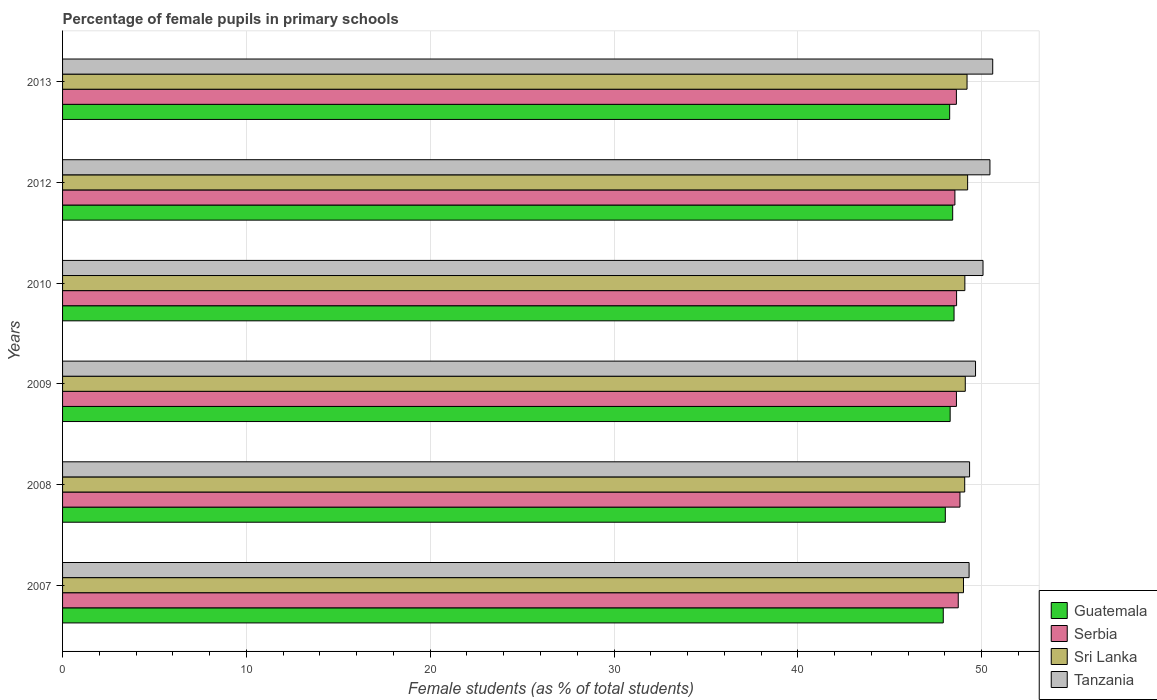How many different coloured bars are there?
Make the answer very short. 4. Are the number of bars per tick equal to the number of legend labels?
Provide a short and direct response. Yes. Are the number of bars on each tick of the Y-axis equal?
Offer a terse response. Yes. How many bars are there on the 5th tick from the bottom?
Make the answer very short. 4. What is the percentage of female pupils in primary schools in Serbia in 2009?
Make the answer very short. 48.63. Across all years, what is the maximum percentage of female pupils in primary schools in Serbia?
Offer a terse response. 48.82. Across all years, what is the minimum percentage of female pupils in primary schools in Sri Lanka?
Offer a very short reply. 49.01. What is the total percentage of female pupils in primary schools in Serbia in the graph?
Make the answer very short. 291.99. What is the difference between the percentage of female pupils in primary schools in Guatemala in 2012 and that in 2013?
Ensure brevity in your answer.  0.16. What is the difference between the percentage of female pupils in primary schools in Sri Lanka in 2008 and the percentage of female pupils in primary schools in Guatemala in 2007?
Your answer should be compact. 1.17. What is the average percentage of female pupils in primary schools in Sri Lanka per year?
Give a very brief answer. 49.12. In the year 2009, what is the difference between the percentage of female pupils in primary schools in Sri Lanka and percentage of female pupils in primary schools in Tanzania?
Provide a short and direct response. -0.56. What is the ratio of the percentage of female pupils in primary schools in Tanzania in 2012 to that in 2013?
Ensure brevity in your answer.  1. What is the difference between the highest and the second highest percentage of female pupils in primary schools in Sri Lanka?
Your answer should be very brief. 0.03. What is the difference between the highest and the lowest percentage of female pupils in primary schools in Tanzania?
Give a very brief answer. 1.29. Is the sum of the percentage of female pupils in primary schools in Tanzania in 2007 and 2010 greater than the maximum percentage of female pupils in primary schools in Guatemala across all years?
Keep it short and to the point. Yes. Is it the case that in every year, the sum of the percentage of female pupils in primary schools in Tanzania and percentage of female pupils in primary schools in Serbia is greater than the sum of percentage of female pupils in primary schools in Guatemala and percentage of female pupils in primary schools in Sri Lanka?
Make the answer very short. No. What does the 3rd bar from the top in 2012 represents?
Your response must be concise. Serbia. What does the 2nd bar from the bottom in 2012 represents?
Keep it short and to the point. Serbia. How many bars are there?
Provide a succinct answer. 24. What is the difference between two consecutive major ticks on the X-axis?
Give a very brief answer. 10. Where does the legend appear in the graph?
Ensure brevity in your answer.  Bottom right. How many legend labels are there?
Provide a succinct answer. 4. What is the title of the graph?
Provide a succinct answer. Percentage of female pupils in primary schools. Does "Slovak Republic" appear as one of the legend labels in the graph?
Offer a terse response. No. What is the label or title of the X-axis?
Give a very brief answer. Female students (as % of total students). What is the label or title of the Y-axis?
Your answer should be very brief. Years. What is the Female students (as % of total students) in Guatemala in 2007?
Your answer should be very brief. 47.91. What is the Female students (as % of total students) in Serbia in 2007?
Offer a terse response. 48.73. What is the Female students (as % of total students) of Sri Lanka in 2007?
Your answer should be very brief. 49.01. What is the Female students (as % of total students) in Tanzania in 2007?
Offer a terse response. 49.32. What is the Female students (as % of total students) in Guatemala in 2008?
Keep it short and to the point. 48.02. What is the Female students (as % of total students) of Serbia in 2008?
Provide a succinct answer. 48.82. What is the Female students (as % of total students) of Sri Lanka in 2008?
Make the answer very short. 49.08. What is the Female students (as % of total students) in Tanzania in 2008?
Make the answer very short. 49.34. What is the Female students (as % of total students) in Guatemala in 2009?
Offer a terse response. 48.29. What is the Female students (as % of total students) in Serbia in 2009?
Your answer should be compact. 48.63. What is the Female students (as % of total students) of Sri Lanka in 2009?
Your answer should be very brief. 49.11. What is the Female students (as % of total students) of Tanzania in 2009?
Give a very brief answer. 49.67. What is the Female students (as % of total students) in Guatemala in 2010?
Your answer should be compact. 48.5. What is the Female students (as % of total students) of Serbia in 2010?
Offer a very short reply. 48.64. What is the Female students (as % of total students) in Sri Lanka in 2010?
Give a very brief answer. 49.09. What is the Female students (as % of total students) of Tanzania in 2010?
Make the answer very short. 50.08. What is the Female students (as % of total students) in Guatemala in 2012?
Your answer should be very brief. 48.43. What is the Female students (as % of total students) of Serbia in 2012?
Your answer should be compact. 48.55. What is the Female students (as % of total students) of Sri Lanka in 2012?
Give a very brief answer. 49.24. What is the Female students (as % of total students) of Tanzania in 2012?
Your answer should be very brief. 50.45. What is the Female students (as % of total students) in Guatemala in 2013?
Give a very brief answer. 48.26. What is the Female students (as % of total students) of Serbia in 2013?
Offer a terse response. 48.63. What is the Female students (as % of total students) of Sri Lanka in 2013?
Provide a succinct answer. 49.21. What is the Female students (as % of total students) in Tanzania in 2013?
Give a very brief answer. 50.6. Across all years, what is the maximum Female students (as % of total students) in Guatemala?
Offer a very short reply. 48.5. Across all years, what is the maximum Female students (as % of total students) of Serbia?
Give a very brief answer. 48.82. Across all years, what is the maximum Female students (as % of total students) in Sri Lanka?
Give a very brief answer. 49.24. Across all years, what is the maximum Female students (as % of total students) in Tanzania?
Your response must be concise. 50.6. Across all years, what is the minimum Female students (as % of total students) in Guatemala?
Give a very brief answer. 47.91. Across all years, what is the minimum Female students (as % of total students) in Serbia?
Provide a short and direct response. 48.55. Across all years, what is the minimum Female students (as % of total students) of Sri Lanka?
Provide a short and direct response. 49.01. Across all years, what is the minimum Female students (as % of total students) in Tanzania?
Offer a very short reply. 49.32. What is the total Female students (as % of total students) of Guatemala in the graph?
Ensure brevity in your answer.  289.41. What is the total Female students (as % of total students) of Serbia in the graph?
Ensure brevity in your answer.  291.99. What is the total Female students (as % of total students) of Sri Lanka in the graph?
Keep it short and to the point. 294.74. What is the total Female students (as % of total students) in Tanzania in the graph?
Make the answer very short. 299.46. What is the difference between the Female students (as % of total students) in Guatemala in 2007 and that in 2008?
Your answer should be compact. -0.11. What is the difference between the Female students (as % of total students) of Serbia in 2007 and that in 2008?
Your response must be concise. -0.09. What is the difference between the Female students (as % of total students) of Sri Lanka in 2007 and that in 2008?
Keep it short and to the point. -0.07. What is the difference between the Female students (as % of total students) of Tanzania in 2007 and that in 2008?
Provide a succinct answer. -0.03. What is the difference between the Female students (as % of total students) in Guatemala in 2007 and that in 2009?
Make the answer very short. -0.37. What is the difference between the Female students (as % of total students) of Serbia in 2007 and that in 2009?
Offer a terse response. 0.1. What is the difference between the Female students (as % of total students) in Sri Lanka in 2007 and that in 2009?
Offer a terse response. -0.1. What is the difference between the Female students (as % of total students) of Tanzania in 2007 and that in 2009?
Ensure brevity in your answer.  -0.35. What is the difference between the Female students (as % of total students) in Guatemala in 2007 and that in 2010?
Offer a terse response. -0.59. What is the difference between the Female students (as % of total students) of Serbia in 2007 and that in 2010?
Keep it short and to the point. 0.09. What is the difference between the Female students (as % of total students) of Sri Lanka in 2007 and that in 2010?
Offer a terse response. -0.07. What is the difference between the Female students (as % of total students) of Tanzania in 2007 and that in 2010?
Ensure brevity in your answer.  -0.76. What is the difference between the Female students (as % of total students) of Guatemala in 2007 and that in 2012?
Your answer should be compact. -0.51. What is the difference between the Female students (as % of total students) in Serbia in 2007 and that in 2012?
Provide a succinct answer. 0.18. What is the difference between the Female students (as % of total students) in Sri Lanka in 2007 and that in 2012?
Ensure brevity in your answer.  -0.23. What is the difference between the Female students (as % of total students) of Tanzania in 2007 and that in 2012?
Ensure brevity in your answer.  -1.13. What is the difference between the Female students (as % of total students) of Guatemala in 2007 and that in 2013?
Provide a short and direct response. -0.35. What is the difference between the Female students (as % of total students) in Serbia in 2007 and that in 2013?
Provide a succinct answer. 0.1. What is the difference between the Female students (as % of total students) in Sri Lanka in 2007 and that in 2013?
Your response must be concise. -0.19. What is the difference between the Female students (as % of total students) in Tanzania in 2007 and that in 2013?
Your answer should be compact. -1.29. What is the difference between the Female students (as % of total students) in Guatemala in 2008 and that in 2009?
Make the answer very short. -0.26. What is the difference between the Female students (as % of total students) of Serbia in 2008 and that in 2009?
Make the answer very short. 0.19. What is the difference between the Female students (as % of total students) in Sri Lanka in 2008 and that in 2009?
Offer a terse response. -0.03. What is the difference between the Female students (as % of total students) in Tanzania in 2008 and that in 2009?
Provide a short and direct response. -0.32. What is the difference between the Female students (as % of total students) of Guatemala in 2008 and that in 2010?
Ensure brevity in your answer.  -0.47. What is the difference between the Female students (as % of total students) of Serbia in 2008 and that in 2010?
Keep it short and to the point. 0.18. What is the difference between the Female students (as % of total students) of Sri Lanka in 2008 and that in 2010?
Keep it short and to the point. -0.01. What is the difference between the Female students (as % of total students) of Tanzania in 2008 and that in 2010?
Make the answer very short. -0.73. What is the difference between the Female students (as % of total students) of Guatemala in 2008 and that in 2012?
Provide a succinct answer. -0.4. What is the difference between the Female students (as % of total students) in Serbia in 2008 and that in 2012?
Provide a succinct answer. 0.28. What is the difference between the Female students (as % of total students) of Sri Lanka in 2008 and that in 2012?
Your answer should be compact. -0.16. What is the difference between the Female students (as % of total students) of Tanzania in 2008 and that in 2012?
Offer a terse response. -1.11. What is the difference between the Female students (as % of total students) in Guatemala in 2008 and that in 2013?
Give a very brief answer. -0.24. What is the difference between the Female students (as % of total students) in Serbia in 2008 and that in 2013?
Provide a short and direct response. 0.19. What is the difference between the Female students (as % of total students) in Sri Lanka in 2008 and that in 2013?
Make the answer very short. -0.13. What is the difference between the Female students (as % of total students) of Tanzania in 2008 and that in 2013?
Give a very brief answer. -1.26. What is the difference between the Female students (as % of total students) in Guatemala in 2009 and that in 2010?
Offer a very short reply. -0.21. What is the difference between the Female students (as % of total students) in Serbia in 2009 and that in 2010?
Offer a terse response. -0.01. What is the difference between the Female students (as % of total students) of Sri Lanka in 2009 and that in 2010?
Provide a short and direct response. 0.02. What is the difference between the Female students (as % of total students) of Tanzania in 2009 and that in 2010?
Offer a terse response. -0.41. What is the difference between the Female students (as % of total students) in Guatemala in 2009 and that in 2012?
Provide a short and direct response. -0.14. What is the difference between the Female students (as % of total students) in Serbia in 2009 and that in 2012?
Your answer should be compact. 0.08. What is the difference between the Female students (as % of total students) in Sri Lanka in 2009 and that in 2012?
Your response must be concise. -0.13. What is the difference between the Female students (as % of total students) in Tanzania in 2009 and that in 2012?
Give a very brief answer. -0.78. What is the difference between the Female students (as % of total students) of Guatemala in 2009 and that in 2013?
Keep it short and to the point. 0.03. What is the difference between the Female students (as % of total students) of Serbia in 2009 and that in 2013?
Your answer should be compact. 0. What is the difference between the Female students (as % of total students) of Sri Lanka in 2009 and that in 2013?
Provide a short and direct response. -0.1. What is the difference between the Female students (as % of total students) in Tanzania in 2009 and that in 2013?
Keep it short and to the point. -0.93. What is the difference between the Female students (as % of total students) of Guatemala in 2010 and that in 2012?
Keep it short and to the point. 0.07. What is the difference between the Female students (as % of total students) in Serbia in 2010 and that in 2012?
Your response must be concise. 0.09. What is the difference between the Female students (as % of total students) in Sri Lanka in 2010 and that in 2012?
Keep it short and to the point. -0.15. What is the difference between the Female students (as % of total students) of Tanzania in 2010 and that in 2012?
Offer a very short reply. -0.38. What is the difference between the Female students (as % of total students) of Guatemala in 2010 and that in 2013?
Your answer should be very brief. 0.24. What is the difference between the Female students (as % of total students) of Serbia in 2010 and that in 2013?
Your answer should be very brief. 0.01. What is the difference between the Female students (as % of total students) in Sri Lanka in 2010 and that in 2013?
Offer a very short reply. -0.12. What is the difference between the Female students (as % of total students) in Tanzania in 2010 and that in 2013?
Make the answer very short. -0.53. What is the difference between the Female students (as % of total students) in Guatemala in 2012 and that in 2013?
Your answer should be compact. 0.16. What is the difference between the Female students (as % of total students) of Serbia in 2012 and that in 2013?
Give a very brief answer. -0.08. What is the difference between the Female students (as % of total students) of Sri Lanka in 2012 and that in 2013?
Offer a very short reply. 0.03. What is the difference between the Female students (as % of total students) in Tanzania in 2012 and that in 2013?
Your response must be concise. -0.15. What is the difference between the Female students (as % of total students) in Guatemala in 2007 and the Female students (as % of total students) in Serbia in 2008?
Make the answer very short. -0.91. What is the difference between the Female students (as % of total students) in Guatemala in 2007 and the Female students (as % of total students) in Sri Lanka in 2008?
Make the answer very short. -1.17. What is the difference between the Female students (as % of total students) of Guatemala in 2007 and the Female students (as % of total students) of Tanzania in 2008?
Your answer should be compact. -1.43. What is the difference between the Female students (as % of total students) in Serbia in 2007 and the Female students (as % of total students) in Sri Lanka in 2008?
Keep it short and to the point. -0.35. What is the difference between the Female students (as % of total students) in Serbia in 2007 and the Female students (as % of total students) in Tanzania in 2008?
Keep it short and to the point. -0.62. What is the difference between the Female students (as % of total students) in Sri Lanka in 2007 and the Female students (as % of total students) in Tanzania in 2008?
Keep it short and to the point. -0.33. What is the difference between the Female students (as % of total students) in Guatemala in 2007 and the Female students (as % of total students) in Serbia in 2009?
Your response must be concise. -0.72. What is the difference between the Female students (as % of total students) of Guatemala in 2007 and the Female students (as % of total students) of Sri Lanka in 2009?
Keep it short and to the point. -1.2. What is the difference between the Female students (as % of total students) of Guatemala in 2007 and the Female students (as % of total students) of Tanzania in 2009?
Make the answer very short. -1.76. What is the difference between the Female students (as % of total students) of Serbia in 2007 and the Female students (as % of total students) of Sri Lanka in 2009?
Your answer should be compact. -0.38. What is the difference between the Female students (as % of total students) in Serbia in 2007 and the Female students (as % of total students) in Tanzania in 2009?
Provide a succinct answer. -0.94. What is the difference between the Female students (as % of total students) in Sri Lanka in 2007 and the Female students (as % of total students) in Tanzania in 2009?
Make the answer very short. -0.66. What is the difference between the Female students (as % of total students) of Guatemala in 2007 and the Female students (as % of total students) of Serbia in 2010?
Your response must be concise. -0.72. What is the difference between the Female students (as % of total students) in Guatemala in 2007 and the Female students (as % of total students) in Sri Lanka in 2010?
Make the answer very short. -1.17. What is the difference between the Female students (as % of total students) of Guatemala in 2007 and the Female students (as % of total students) of Tanzania in 2010?
Provide a succinct answer. -2.16. What is the difference between the Female students (as % of total students) in Serbia in 2007 and the Female students (as % of total students) in Sri Lanka in 2010?
Keep it short and to the point. -0.36. What is the difference between the Female students (as % of total students) in Serbia in 2007 and the Female students (as % of total students) in Tanzania in 2010?
Provide a short and direct response. -1.35. What is the difference between the Female students (as % of total students) of Sri Lanka in 2007 and the Female students (as % of total students) of Tanzania in 2010?
Your answer should be very brief. -1.06. What is the difference between the Female students (as % of total students) in Guatemala in 2007 and the Female students (as % of total students) in Serbia in 2012?
Offer a terse response. -0.63. What is the difference between the Female students (as % of total students) in Guatemala in 2007 and the Female students (as % of total students) in Sri Lanka in 2012?
Offer a terse response. -1.33. What is the difference between the Female students (as % of total students) of Guatemala in 2007 and the Female students (as % of total students) of Tanzania in 2012?
Provide a short and direct response. -2.54. What is the difference between the Female students (as % of total students) in Serbia in 2007 and the Female students (as % of total students) in Sri Lanka in 2012?
Give a very brief answer. -0.51. What is the difference between the Female students (as % of total students) of Serbia in 2007 and the Female students (as % of total students) of Tanzania in 2012?
Give a very brief answer. -1.72. What is the difference between the Female students (as % of total students) in Sri Lanka in 2007 and the Female students (as % of total students) in Tanzania in 2012?
Make the answer very short. -1.44. What is the difference between the Female students (as % of total students) in Guatemala in 2007 and the Female students (as % of total students) in Serbia in 2013?
Offer a terse response. -0.71. What is the difference between the Female students (as % of total students) in Guatemala in 2007 and the Female students (as % of total students) in Sri Lanka in 2013?
Keep it short and to the point. -1.29. What is the difference between the Female students (as % of total students) of Guatemala in 2007 and the Female students (as % of total students) of Tanzania in 2013?
Provide a short and direct response. -2.69. What is the difference between the Female students (as % of total students) of Serbia in 2007 and the Female students (as % of total students) of Sri Lanka in 2013?
Your answer should be very brief. -0.48. What is the difference between the Female students (as % of total students) in Serbia in 2007 and the Female students (as % of total students) in Tanzania in 2013?
Your answer should be very brief. -1.88. What is the difference between the Female students (as % of total students) of Sri Lanka in 2007 and the Female students (as % of total students) of Tanzania in 2013?
Provide a short and direct response. -1.59. What is the difference between the Female students (as % of total students) in Guatemala in 2008 and the Female students (as % of total students) in Serbia in 2009?
Ensure brevity in your answer.  -0.6. What is the difference between the Female students (as % of total students) of Guatemala in 2008 and the Female students (as % of total students) of Sri Lanka in 2009?
Your response must be concise. -1.09. What is the difference between the Female students (as % of total students) of Guatemala in 2008 and the Female students (as % of total students) of Tanzania in 2009?
Provide a short and direct response. -1.64. What is the difference between the Female students (as % of total students) in Serbia in 2008 and the Female students (as % of total students) in Sri Lanka in 2009?
Offer a terse response. -0.29. What is the difference between the Female students (as % of total students) of Serbia in 2008 and the Female students (as % of total students) of Tanzania in 2009?
Offer a terse response. -0.85. What is the difference between the Female students (as % of total students) in Sri Lanka in 2008 and the Female students (as % of total students) in Tanzania in 2009?
Offer a very short reply. -0.59. What is the difference between the Female students (as % of total students) in Guatemala in 2008 and the Female students (as % of total students) in Serbia in 2010?
Provide a short and direct response. -0.61. What is the difference between the Female students (as % of total students) in Guatemala in 2008 and the Female students (as % of total students) in Sri Lanka in 2010?
Keep it short and to the point. -1.06. What is the difference between the Female students (as % of total students) of Guatemala in 2008 and the Female students (as % of total students) of Tanzania in 2010?
Your response must be concise. -2.05. What is the difference between the Female students (as % of total students) of Serbia in 2008 and the Female students (as % of total students) of Sri Lanka in 2010?
Make the answer very short. -0.27. What is the difference between the Female students (as % of total students) of Serbia in 2008 and the Female students (as % of total students) of Tanzania in 2010?
Give a very brief answer. -1.25. What is the difference between the Female students (as % of total students) of Sri Lanka in 2008 and the Female students (as % of total students) of Tanzania in 2010?
Provide a succinct answer. -1. What is the difference between the Female students (as % of total students) of Guatemala in 2008 and the Female students (as % of total students) of Serbia in 2012?
Keep it short and to the point. -0.52. What is the difference between the Female students (as % of total students) of Guatemala in 2008 and the Female students (as % of total students) of Sri Lanka in 2012?
Offer a terse response. -1.21. What is the difference between the Female students (as % of total students) in Guatemala in 2008 and the Female students (as % of total students) in Tanzania in 2012?
Make the answer very short. -2.43. What is the difference between the Female students (as % of total students) in Serbia in 2008 and the Female students (as % of total students) in Sri Lanka in 2012?
Your answer should be compact. -0.42. What is the difference between the Female students (as % of total students) of Serbia in 2008 and the Female students (as % of total students) of Tanzania in 2012?
Provide a short and direct response. -1.63. What is the difference between the Female students (as % of total students) in Sri Lanka in 2008 and the Female students (as % of total students) in Tanzania in 2012?
Keep it short and to the point. -1.37. What is the difference between the Female students (as % of total students) in Guatemala in 2008 and the Female students (as % of total students) in Serbia in 2013?
Offer a very short reply. -0.6. What is the difference between the Female students (as % of total students) of Guatemala in 2008 and the Female students (as % of total students) of Sri Lanka in 2013?
Offer a terse response. -1.18. What is the difference between the Female students (as % of total students) of Guatemala in 2008 and the Female students (as % of total students) of Tanzania in 2013?
Ensure brevity in your answer.  -2.58. What is the difference between the Female students (as % of total students) in Serbia in 2008 and the Female students (as % of total students) in Sri Lanka in 2013?
Make the answer very short. -0.38. What is the difference between the Female students (as % of total students) in Serbia in 2008 and the Female students (as % of total students) in Tanzania in 2013?
Keep it short and to the point. -1.78. What is the difference between the Female students (as % of total students) in Sri Lanka in 2008 and the Female students (as % of total students) in Tanzania in 2013?
Provide a short and direct response. -1.52. What is the difference between the Female students (as % of total students) in Guatemala in 2009 and the Female students (as % of total students) in Serbia in 2010?
Make the answer very short. -0.35. What is the difference between the Female students (as % of total students) of Guatemala in 2009 and the Female students (as % of total students) of Sri Lanka in 2010?
Give a very brief answer. -0.8. What is the difference between the Female students (as % of total students) of Guatemala in 2009 and the Female students (as % of total students) of Tanzania in 2010?
Your response must be concise. -1.79. What is the difference between the Female students (as % of total students) of Serbia in 2009 and the Female students (as % of total students) of Sri Lanka in 2010?
Your response must be concise. -0.46. What is the difference between the Female students (as % of total students) in Serbia in 2009 and the Female students (as % of total students) in Tanzania in 2010?
Make the answer very short. -1.45. What is the difference between the Female students (as % of total students) of Sri Lanka in 2009 and the Female students (as % of total students) of Tanzania in 2010?
Make the answer very short. -0.97. What is the difference between the Female students (as % of total students) of Guatemala in 2009 and the Female students (as % of total students) of Serbia in 2012?
Your answer should be compact. -0.26. What is the difference between the Female students (as % of total students) of Guatemala in 2009 and the Female students (as % of total students) of Sri Lanka in 2012?
Your answer should be very brief. -0.95. What is the difference between the Female students (as % of total students) in Guatemala in 2009 and the Female students (as % of total students) in Tanzania in 2012?
Provide a succinct answer. -2.16. What is the difference between the Female students (as % of total students) in Serbia in 2009 and the Female students (as % of total students) in Sri Lanka in 2012?
Your response must be concise. -0.61. What is the difference between the Female students (as % of total students) of Serbia in 2009 and the Female students (as % of total students) of Tanzania in 2012?
Offer a terse response. -1.82. What is the difference between the Female students (as % of total students) of Sri Lanka in 2009 and the Female students (as % of total students) of Tanzania in 2012?
Your answer should be compact. -1.34. What is the difference between the Female students (as % of total students) in Guatemala in 2009 and the Female students (as % of total students) in Serbia in 2013?
Offer a terse response. -0.34. What is the difference between the Female students (as % of total students) of Guatemala in 2009 and the Female students (as % of total students) of Sri Lanka in 2013?
Keep it short and to the point. -0.92. What is the difference between the Female students (as % of total students) of Guatemala in 2009 and the Female students (as % of total students) of Tanzania in 2013?
Keep it short and to the point. -2.32. What is the difference between the Female students (as % of total students) in Serbia in 2009 and the Female students (as % of total students) in Sri Lanka in 2013?
Provide a succinct answer. -0.58. What is the difference between the Female students (as % of total students) of Serbia in 2009 and the Female students (as % of total students) of Tanzania in 2013?
Provide a short and direct response. -1.97. What is the difference between the Female students (as % of total students) of Sri Lanka in 2009 and the Female students (as % of total students) of Tanzania in 2013?
Provide a short and direct response. -1.49. What is the difference between the Female students (as % of total students) in Guatemala in 2010 and the Female students (as % of total students) in Serbia in 2012?
Your answer should be very brief. -0.05. What is the difference between the Female students (as % of total students) of Guatemala in 2010 and the Female students (as % of total students) of Sri Lanka in 2012?
Offer a very short reply. -0.74. What is the difference between the Female students (as % of total students) in Guatemala in 2010 and the Female students (as % of total students) in Tanzania in 2012?
Give a very brief answer. -1.95. What is the difference between the Female students (as % of total students) of Serbia in 2010 and the Female students (as % of total students) of Sri Lanka in 2012?
Your answer should be compact. -0.6. What is the difference between the Female students (as % of total students) in Serbia in 2010 and the Female students (as % of total students) in Tanzania in 2012?
Your response must be concise. -1.81. What is the difference between the Female students (as % of total students) of Sri Lanka in 2010 and the Female students (as % of total students) of Tanzania in 2012?
Make the answer very short. -1.36. What is the difference between the Female students (as % of total students) in Guatemala in 2010 and the Female students (as % of total students) in Serbia in 2013?
Provide a short and direct response. -0.13. What is the difference between the Female students (as % of total students) of Guatemala in 2010 and the Female students (as % of total students) of Sri Lanka in 2013?
Your answer should be very brief. -0.71. What is the difference between the Female students (as % of total students) of Guatemala in 2010 and the Female students (as % of total students) of Tanzania in 2013?
Offer a terse response. -2.1. What is the difference between the Female students (as % of total students) in Serbia in 2010 and the Female students (as % of total students) in Sri Lanka in 2013?
Your answer should be very brief. -0.57. What is the difference between the Female students (as % of total students) in Serbia in 2010 and the Female students (as % of total students) in Tanzania in 2013?
Make the answer very short. -1.97. What is the difference between the Female students (as % of total students) of Sri Lanka in 2010 and the Female students (as % of total students) of Tanzania in 2013?
Your answer should be very brief. -1.52. What is the difference between the Female students (as % of total students) in Guatemala in 2012 and the Female students (as % of total students) in Serbia in 2013?
Your answer should be very brief. -0.2. What is the difference between the Female students (as % of total students) in Guatemala in 2012 and the Female students (as % of total students) in Sri Lanka in 2013?
Provide a succinct answer. -0.78. What is the difference between the Female students (as % of total students) in Guatemala in 2012 and the Female students (as % of total students) in Tanzania in 2013?
Your response must be concise. -2.18. What is the difference between the Female students (as % of total students) of Serbia in 2012 and the Female students (as % of total students) of Sri Lanka in 2013?
Ensure brevity in your answer.  -0.66. What is the difference between the Female students (as % of total students) of Serbia in 2012 and the Female students (as % of total students) of Tanzania in 2013?
Your answer should be compact. -2.06. What is the difference between the Female students (as % of total students) of Sri Lanka in 2012 and the Female students (as % of total students) of Tanzania in 2013?
Provide a succinct answer. -1.36. What is the average Female students (as % of total students) of Guatemala per year?
Your answer should be very brief. 48.24. What is the average Female students (as % of total students) in Serbia per year?
Give a very brief answer. 48.67. What is the average Female students (as % of total students) in Sri Lanka per year?
Ensure brevity in your answer.  49.12. What is the average Female students (as % of total students) of Tanzania per year?
Give a very brief answer. 49.91. In the year 2007, what is the difference between the Female students (as % of total students) of Guatemala and Female students (as % of total students) of Serbia?
Your answer should be compact. -0.81. In the year 2007, what is the difference between the Female students (as % of total students) in Guatemala and Female students (as % of total students) in Sri Lanka?
Your response must be concise. -1.1. In the year 2007, what is the difference between the Female students (as % of total students) of Guatemala and Female students (as % of total students) of Tanzania?
Offer a very short reply. -1.41. In the year 2007, what is the difference between the Female students (as % of total students) of Serbia and Female students (as % of total students) of Sri Lanka?
Give a very brief answer. -0.28. In the year 2007, what is the difference between the Female students (as % of total students) in Serbia and Female students (as % of total students) in Tanzania?
Offer a very short reply. -0.59. In the year 2007, what is the difference between the Female students (as % of total students) in Sri Lanka and Female students (as % of total students) in Tanzania?
Your answer should be very brief. -0.31. In the year 2008, what is the difference between the Female students (as % of total students) in Guatemala and Female students (as % of total students) in Serbia?
Provide a short and direct response. -0.8. In the year 2008, what is the difference between the Female students (as % of total students) in Guatemala and Female students (as % of total students) in Sri Lanka?
Ensure brevity in your answer.  -1.05. In the year 2008, what is the difference between the Female students (as % of total students) in Guatemala and Female students (as % of total students) in Tanzania?
Your answer should be very brief. -1.32. In the year 2008, what is the difference between the Female students (as % of total students) of Serbia and Female students (as % of total students) of Sri Lanka?
Provide a short and direct response. -0.26. In the year 2008, what is the difference between the Female students (as % of total students) in Serbia and Female students (as % of total students) in Tanzania?
Offer a terse response. -0.52. In the year 2008, what is the difference between the Female students (as % of total students) of Sri Lanka and Female students (as % of total students) of Tanzania?
Offer a terse response. -0.27. In the year 2009, what is the difference between the Female students (as % of total students) in Guatemala and Female students (as % of total students) in Serbia?
Make the answer very short. -0.34. In the year 2009, what is the difference between the Female students (as % of total students) of Guatemala and Female students (as % of total students) of Sri Lanka?
Provide a short and direct response. -0.82. In the year 2009, what is the difference between the Female students (as % of total students) of Guatemala and Female students (as % of total students) of Tanzania?
Your answer should be very brief. -1.38. In the year 2009, what is the difference between the Female students (as % of total students) of Serbia and Female students (as % of total students) of Sri Lanka?
Ensure brevity in your answer.  -0.48. In the year 2009, what is the difference between the Female students (as % of total students) of Serbia and Female students (as % of total students) of Tanzania?
Provide a succinct answer. -1.04. In the year 2009, what is the difference between the Female students (as % of total students) in Sri Lanka and Female students (as % of total students) in Tanzania?
Provide a succinct answer. -0.56. In the year 2010, what is the difference between the Female students (as % of total students) in Guatemala and Female students (as % of total students) in Serbia?
Offer a terse response. -0.14. In the year 2010, what is the difference between the Female students (as % of total students) of Guatemala and Female students (as % of total students) of Sri Lanka?
Your response must be concise. -0.59. In the year 2010, what is the difference between the Female students (as % of total students) of Guatemala and Female students (as % of total students) of Tanzania?
Provide a short and direct response. -1.58. In the year 2010, what is the difference between the Female students (as % of total students) of Serbia and Female students (as % of total students) of Sri Lanka?
Give a very brief answer. -0.45. In the year 2010, what is the difference between the Female students (as % of total students) of Serbia and Female students (as % of total students) of Tanzania?
Keep it short and to the point. -1.44. In the year 2010, what is the difference between the Female students (as % of total students) of Sri Lanka and Female students (as % of total students) of Tanzania?
Make the answer very short. -0.99. In the year 2012, what is the difference between the Female students (as % of total students) of Guatemala and Female students (as % of total students) of Serbia?
Your answer should be very brief. -0.12. In the year 2012, what is the difference between the Female students (as % of total students) of Guatemala and Female students (as % of total students) of Sri Lanka?
Offer a very short reply. -0.81. In the year 2012, what is the difference between the Female students (as % of total students) in Guatemala and Female students (as % of total students) in Tanzania?
Your answer should be compact. -2.03. In the year 2012, what is the difference between the Female students (as % of total students) of Serbia and Female students (as % of total students) of Sri Lanka?
Make the answer very short. -0.69. In the year 2012, what is the difference between the Female students (as % of total students) in Serbia and Female students (as % of total students) in Tanzania?
Give a very brief answer. -1.91. In the year 2012, what is the difference between the Female students (as % of total students) in Sri Lanka and Female students (as % of total students) in Tanzania?
Provide a short and direct response. -1.21. In the year 2013, what is the difference between the Female students (as % of total students) in Guatemala and Female students (as % of total students) in Serbia?
Provide a succinct answer. -0.37. In the year 2013, what is the difference between the Female students (as % of total students) of Guatemala and Female students (as % of total students) of Sri Lanka?
Provide a short and direct response. -0.95. In the year 2013, what is the difference between the Female students (as % of total students) in Guatemala and Female students (as % of total students) in Tanzania?
Offer a terse response. -2.34. In the year 2013, what is the difference between the Female students (as % of total students) in Serbia and Female students (as % of total students) in Sri Lanka?
Offer a very short reply. -0.58. In the year 2013, what is the difference between the Female students (as % of total students) of Serbia and Female students (as % of total students) of Tanzania?
Provide a short and direct response. -1.98. In the year 2013, what is the difference between the Female students (as % of total students) in Sri Lanka and Female students (as % of total students) in Tanzania?
Offer a very short reply. -1.4. What is the ratio of the Female students (as % of total students) in Guatemala in 2007 to that in 2008?
Your answer should be compact. 1. What is the ratio of the Female students (as % of total students) in Guatemala in 2007 to that in 2009?
Your answer should be compact. 0.99. What is the ratio of the Female students (as % of total students) in Sri Lanka in 2007 to that in 2009?
Your answer should be compact. 1. What is the ratio of the Female students (as % of total students) of Tanzania in 2007 to that in 2009?
Give a very brief answer. 0.99. What is the ratio of the Female students (as % of total students) of Guatemala in 2007 to that in 2010?
Provide a succinct answer. 0.99. What is the ratio of the Female students (as % of total students) of Sri Lanka in 2007 to that in 2010?
Provide a short and direct response. 1. What is the ratio of the Female students (as % of total students) in Tanzania in 2007 to that in 2010?
Your answer should be very brief. 0.98. What is the ratio of the Female students (as % of total students) of Serbia in 2007 to that in 2012?
Ensure brevity in your answer.  1. What is the ratio of the Female students (as % of total students) in Tanzania in 2007 to that in 2012?
Ensure brevity in your answer.  0.98. What is the ratio of the Female students (as % of total students) in Tanzania in 2007 to that in 2013?
Your answer should be compact. 0.97. What is the ratio of the Female students (as % of total students) of Guatemala in 2008 to that in 2009?
Offer a very short reply. 0.99. What is the ratio of the Female students (as % of total students) in Serbia in 2008 to that in 2009?
Keep it short and to the point. 1. What is the ratio of the Female students (as % of total students) of Sri Lanka in 2008 to that in 2009?
Provide a short and direct response. 1. What is the ratio of the Female students (as % of total students) in Guatemala in 2008 to that in 2010?
Offer a very short reply. 0.99. What is the ratio of the Female students (as % of total students) of Tanzania in 2008 to that in 2010?
Your response must be concise. 0.99. What is the ratio of the Female students (as % of total students) in Serbia in 2008 to that in 2012?
Your answer should be very brief. 1.01. What is the ratio of the Female students (as % of total students) in Guatemala in 2008 to that in 2013?
Keep it short and to the point. 1. What is the ratio of the Female students (as % of total students) in Sri Lanka in 2008 to that in 2013?
Offer a terse response. 1. What is the ratio of the Female students (as % of total students) in Tanzania in 2008 to that in 2013?
Offer a very short reply. 0.98. What is the ratio of the Female students (as % of total students) of Guatemala in 2009 to that in 2010?
Keep it short and to the point. 1. What is the ratio of the Female students (as % of total students) of Sri Lanka in 2009 to that in 2010?
Offer a very short reply. 1. What is the ratio of the Female students (as % of total students) of Guatemala in 2009 to that in 2012?
Ensure brevity in your answer.  1. What is the ratio of the Female students (as % of total students) in Tanzania in 2009 to that in 2012?
Provide a short and direct response. 0.98. What is the ratio of the Female students (as % of total students) of Serbia in 2009 to that in 2013?
Your answer should be very brief. 1. What is the ratio of the Female students (as % of total students) in Sri Lanka in 2009 to that in 2013?
Your answer should be compact. 1. What is the ratio of the Female students (as % of total students) of Tanzania in 2009 to that in 2013?
Your response must be concise. 0.98. What is the ratio of the Female students (as % of total students) in Guatemala in 2010 to that in 2012?
Offer a very short reply. 1. What is the ratio of the Female students (as % of total students) in Serbia in 2010 to that in 2012?
Make the answer very short. 1. What is the ratio of the Female students (as % of total students) in Sri Lanka in 2010 to that in 2012?
Provide a succinct answer. 1. What is the ratio of the Female students (as % of total students) of Tanzania in 2010 to that in 2012?
Offer a terse response. 0.99. What is the ratio of the Female students (as % of total students) of Guatemala in 2010 to that in 2013?
Make the answer very short. 1. What is the ratio of the Female students (as % of total students) of Serbia in 2010 to that in 2013?
Provide a short and direct response. 1. What is the ratio of the Female students (as % of total students) of Sri Lanka in 2010 to that in 2013?
Keep it short and to the point. 1. What is the ratio of the Female students (as % of total students) of Tanzania in 2010 to that in 2013?
Make the answer very short. 0.99. What is the ratio of the Female students (as % of total students) in Guatemala in 2012 to that in 2013?
Give a very brief answer. 1. What is the ratio of the Female students (as % of total students) in Serbia in 2012 to that in 2013?
Offer a terse response. 1. What is the ratio of the Female students (as % of total students) of Sri Lanka in 2012 to that in 2013?
Give a very brief answer. 1. What is the difference between the highest and the second highest Female students (as % of total students) of Guatemala?
Provide a succinct answer. 0.07. What is the difference between the highest and the second highest Female students (as % of total students) of Serbia?
Provide a short and direct response. 0.09. What is the difference between the highest and the second highest Female students (as % of total students) of Sri Lanka?
Your answer should be compact. 0.03. What is the difference between the highest and the second highest Female students (as % of total students) in Tanzania?
Your answer should be compact. 0.15. What is the difference between the highest and the lowest Female students (as % of total students) in Guatemala?
Your response must be concise. 0.59. What is the difference between the highest and the lowest Female students (as % of total students) in Serbia?
Give a very brief answer. 0.28. What is the difference between the highest and the lowest Female students (as % of total students) of Sri Lanka?
Ensure brevity in your answer.  0.23. What is the difference between the highest and the lowest Female students (as % of total students) of Tanzania?
Give a very brief answer. 1.29. 